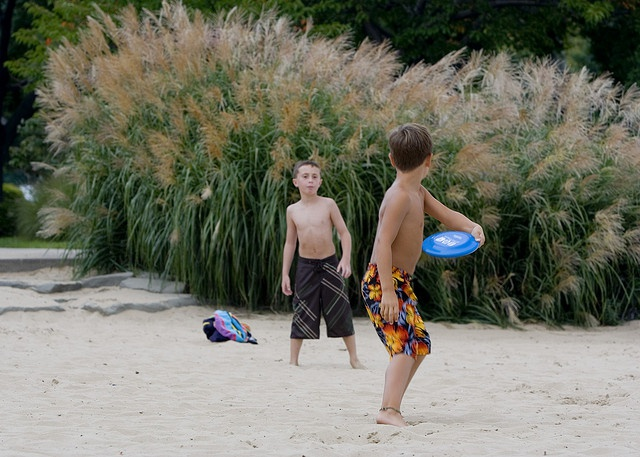Describe the objects in this image and their specific colors. I can see people in black, gray, and darkgray tones, people in black, darkgray, and gray tones, and frisbee in black, lightblue, and gray tones in this image. 